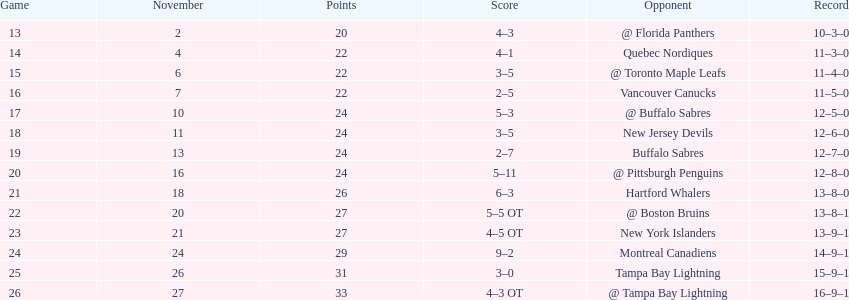What was the number of wins the philadelphia flyers had? 35. 